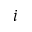<formula> <loc_0><loc_0><loc_500><loc_500>i</formula> 